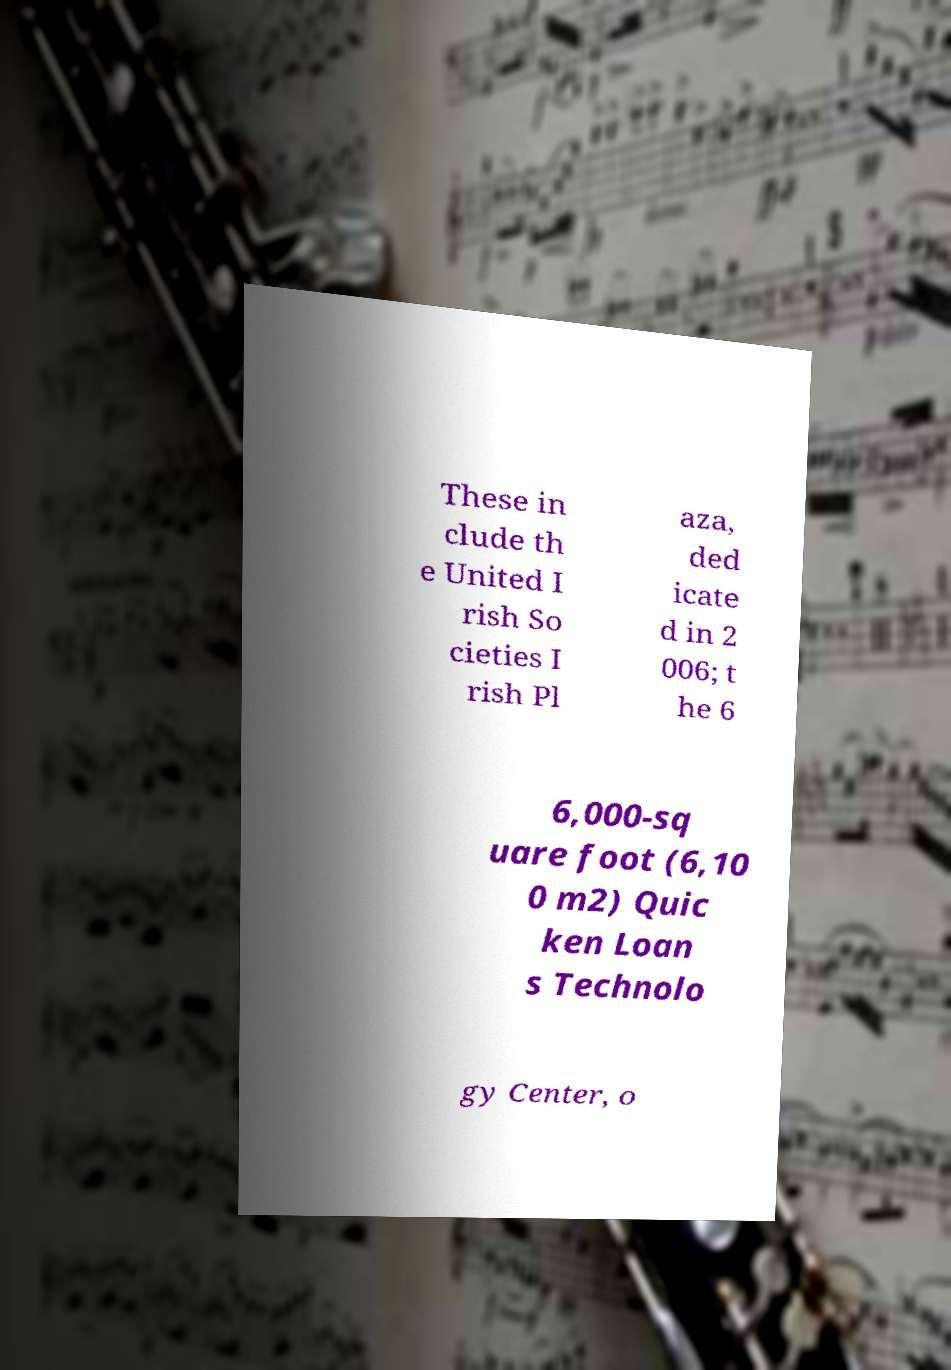Can you accurately transcribe the text from the provided image for me? These in clude th e United I rish So cieties I rish Pl aza, ded icate d in 2 006; t he 6 6,000-sq uare foot (6,10 0 m2) Quic ken Loan s Technolo gy Center, o 